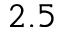<formula> <loc_0><loc_0><loc_500><loc_500>2 . 5</formula> 